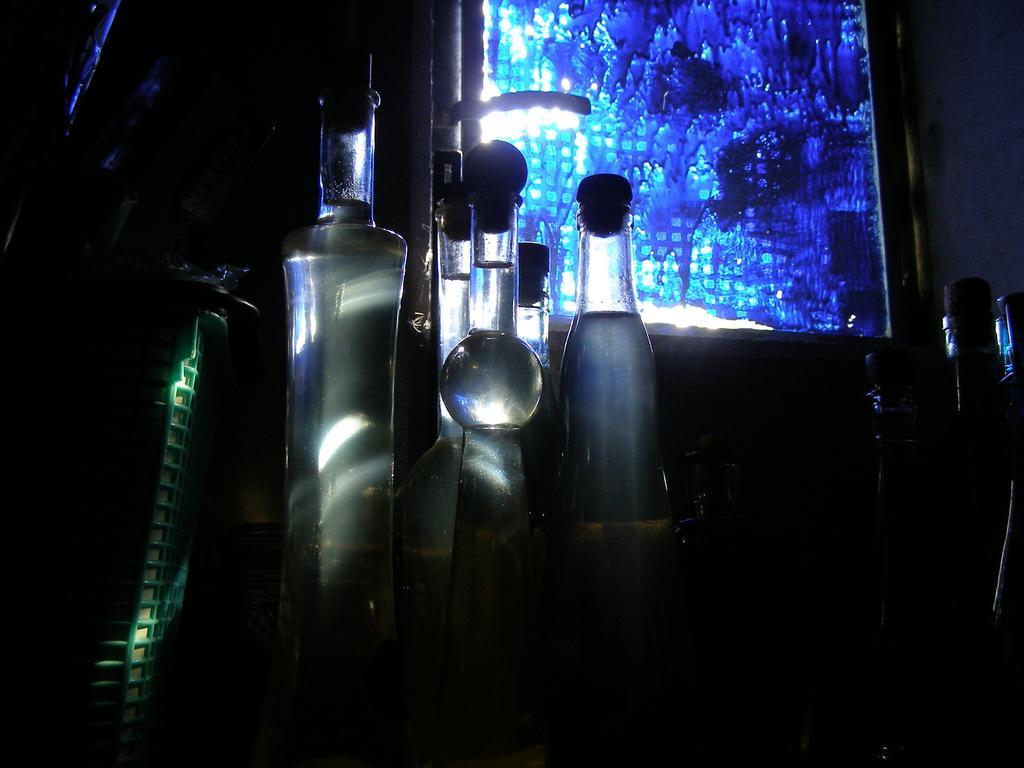Describe this image in one or two sentences. This picture shows few bottles 